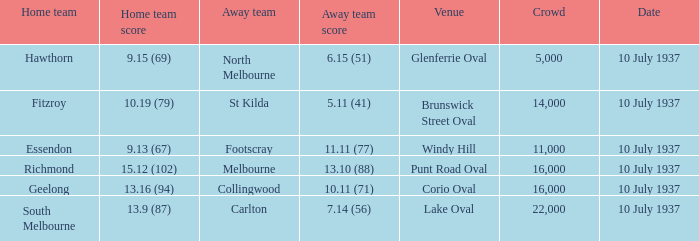11 (71)? 16000.0. 